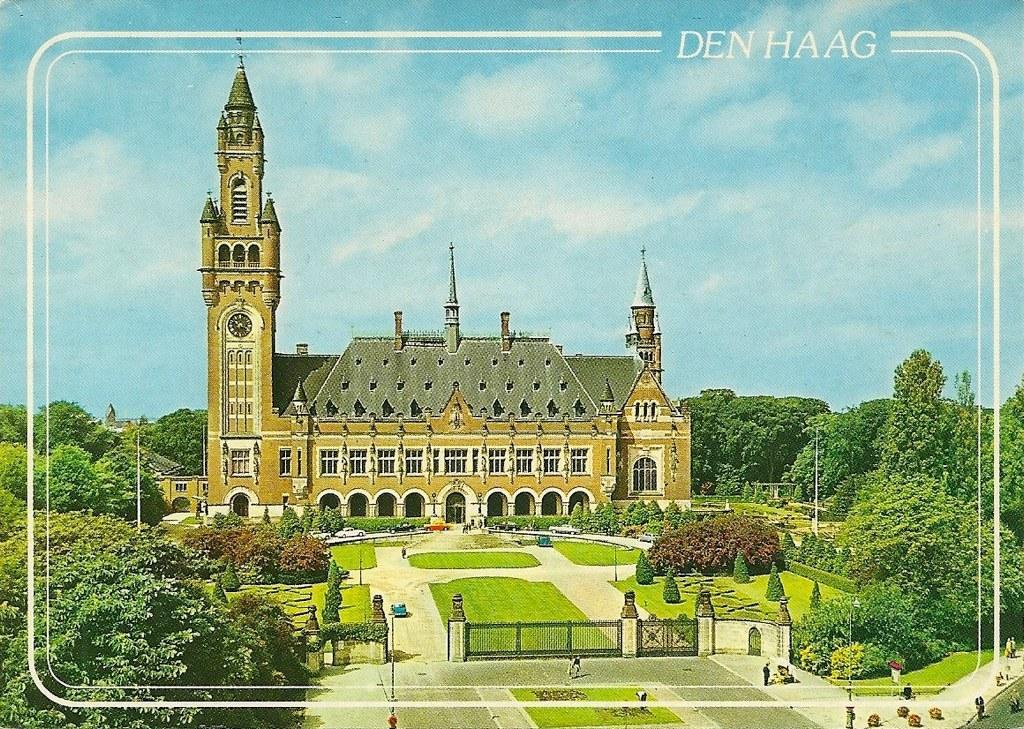Describe this image in one or two sentences. In the foreground of this poster, there are trees, poles, gate, road and lawns. In the background, there are trees, buildings, path to walk, sky and the cloud. 